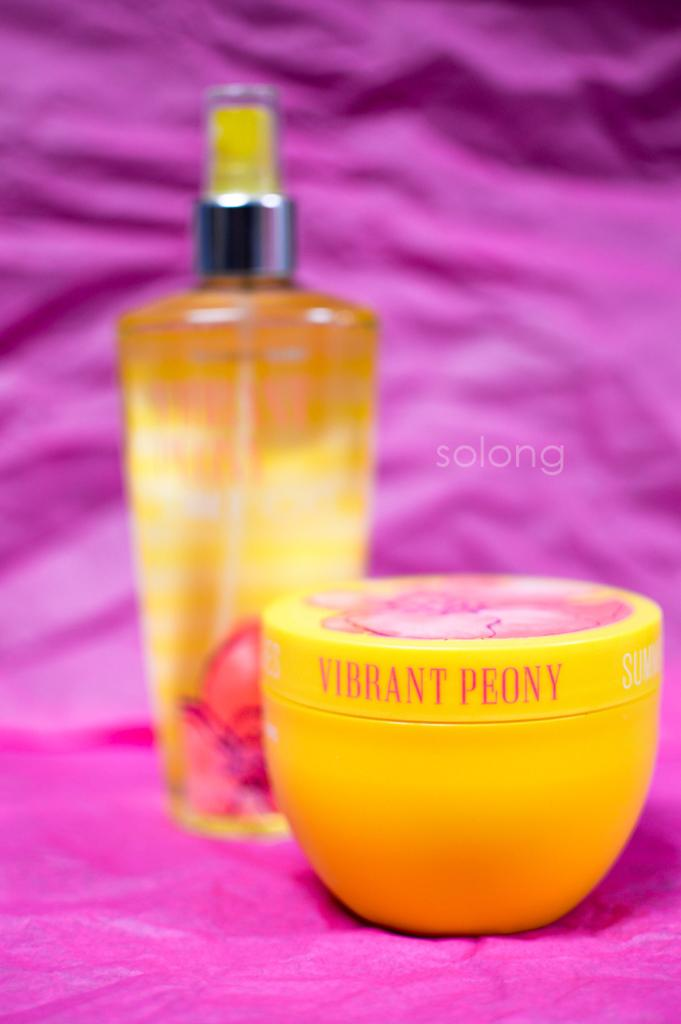Provide a one-sentence caption for the provided image. Vibrant Peony mist and lotion being displayed on top of a pink backdrop. 